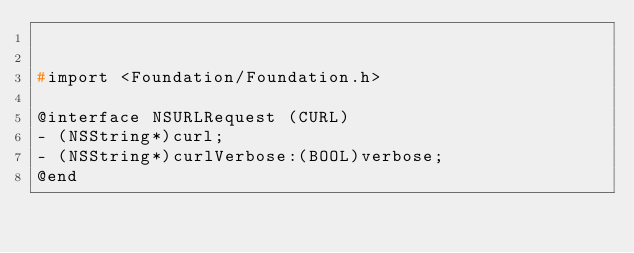Convert code to text. <code><loc_0><loc_0><loc_500><loc_500><_C_>

#import <Foundation/Foundation.h>

@interface NSURLRequest (CURL)
- (NSString*)curl;
- (NSString*)curlVerbose:(BOOL)verbose;
@end
</code> 